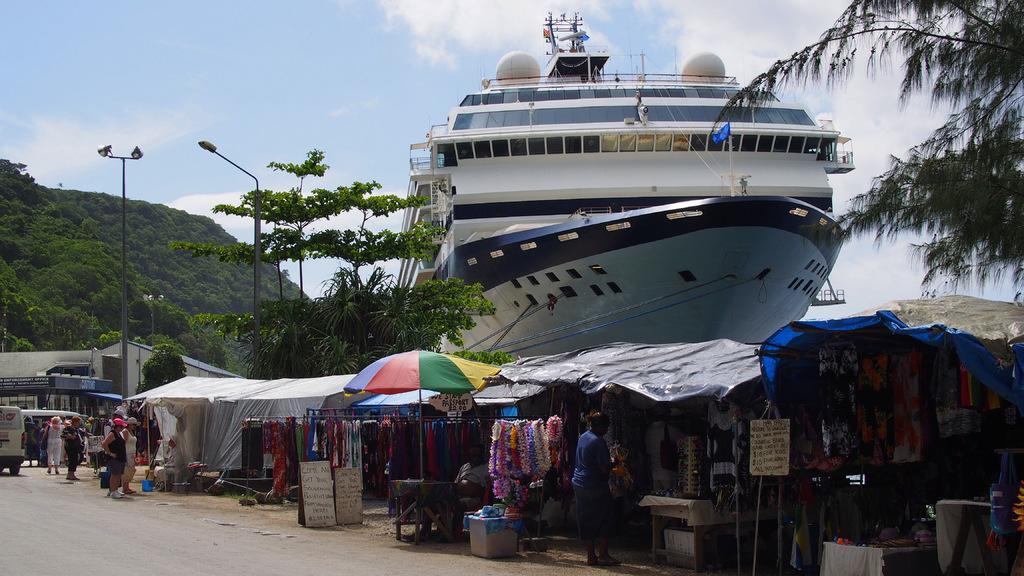How would you summarize this image in a sentence or two? In this image, we can see some people, vehicles and the ground with some objects. We can also see some clothes and stores. We can see some boards with text. There are a few trees, poles. We can see the sky with clouds. We can also see a ship. 